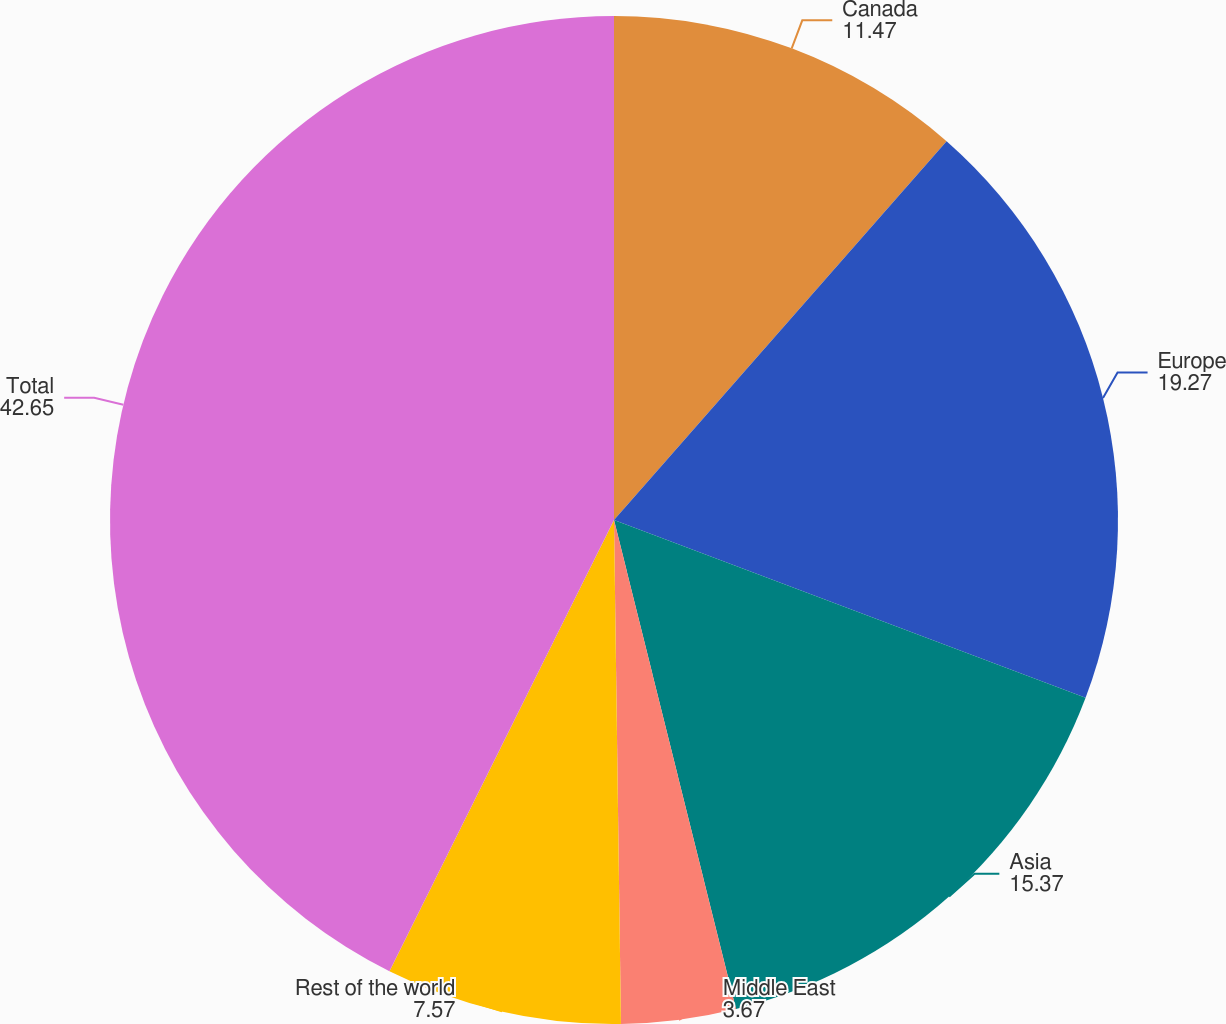Convert chart to OTSL. <chart><loc_0><loc_0><loc_500><loc_500><pie_chart><fcel>Canada<fcel>Europe<fcel>Asia<fcel>Middle East<fcel>Rest of the world<fcel>Total<nl><fcel>11.47%<fcel>19.27%<fcel>15.37%<fcel>3.67%<fcel>7.57%<fcel>42.65%<nl></chart> 